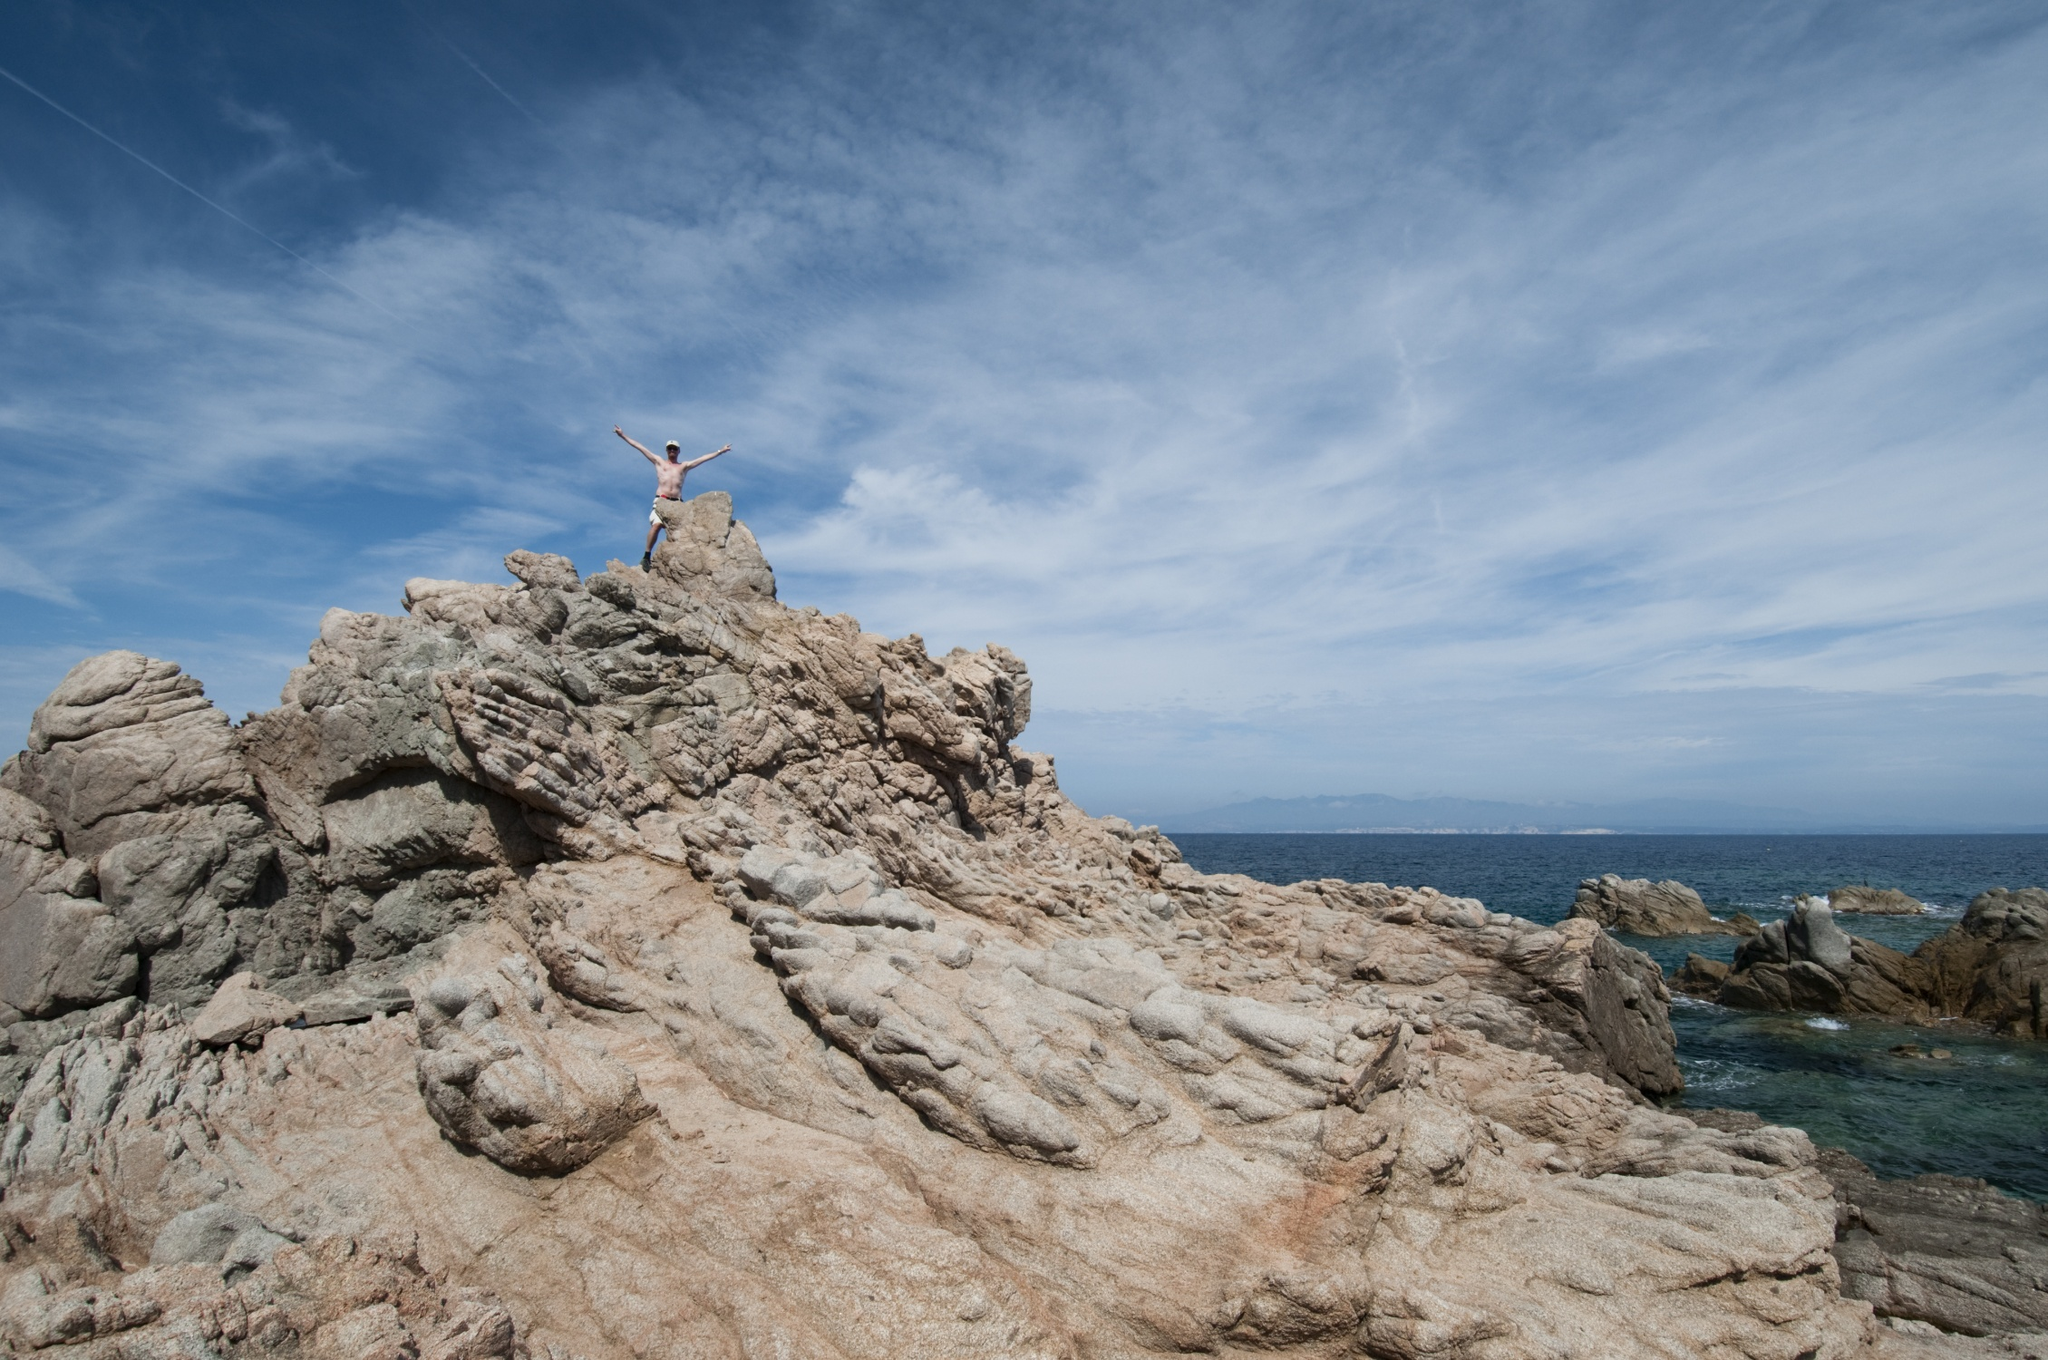If this image were used as inspiration for a painting, how might an artist interpret it? An artist might interpret this image with bold, sweeping brushstrokes to capture the dynamic energy and triumphant spirit of the scene. They could use vibrant blues to illustrate the sky and ocean, blending them seamlessly to emphasize the infinite horizon. The rugged cliffs could be depicted with textured, earthy tones, highlighting the contrast between the solid ground and the fluidity of the water. The person standing on the cliff might be painted in bright, luminous colors, symbolizing their victory and vitality, becoming the focal point of the piece. The overall artwork would evoke a sense of awe and inspiration, capturing the essence of human determination and the majesty of nature. What might be a very imaginative scenario involving mythical creatures in this setting? In a world of legends and myths, this cliff is known as the 'Watcher's Peak,' a sacred place where the boundary between the mortal realm and the mystical sea kingdom blurs. The person standing atop the cliff is a chosen guardian, entrusted with a sacred task by the sea goddess. Below the waves, a kingdom of merfolk and sea creatures thrives, hidden from human eyes. Each year, the guardian must stand on the peak during the full moon, a time when the magical barrier thins, allowing them to communicate with the sea goddess. On this special night, the guardian performs an ancient ritual, summoning majestic sea dragons and luminous mermaids who soar out of the ocean, their scales glittering like stars under the moonlight. This ceremonial convergence strengthens the bond between land and sea, ensuring balance and harmony in the natural world. 